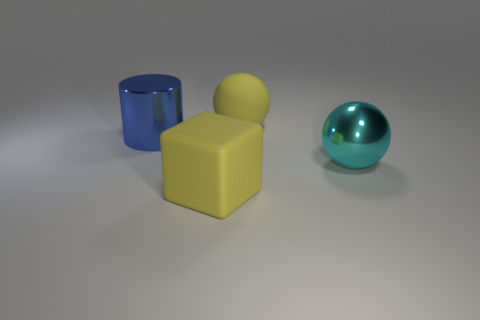Add 2 metal things. How many objects exist? 6 Subtract 1 cylinders. How many cylinders are left? 0 Subtract 1 cyan balls. How many objects are left? 3 Subtract all blocks. How many objects are left? 3 Subtract all gray cylinders. Subtract all yellow blocks. How many cylinders are left? 1 Subtract all large yellow balls. Subtract all cylinders. How many objects are left? 2 Add 3 big yellow rubber blocks. How many big yellow rubber blocks are left? 4 Add 1 matte balls. How many matte balls exist? 2 